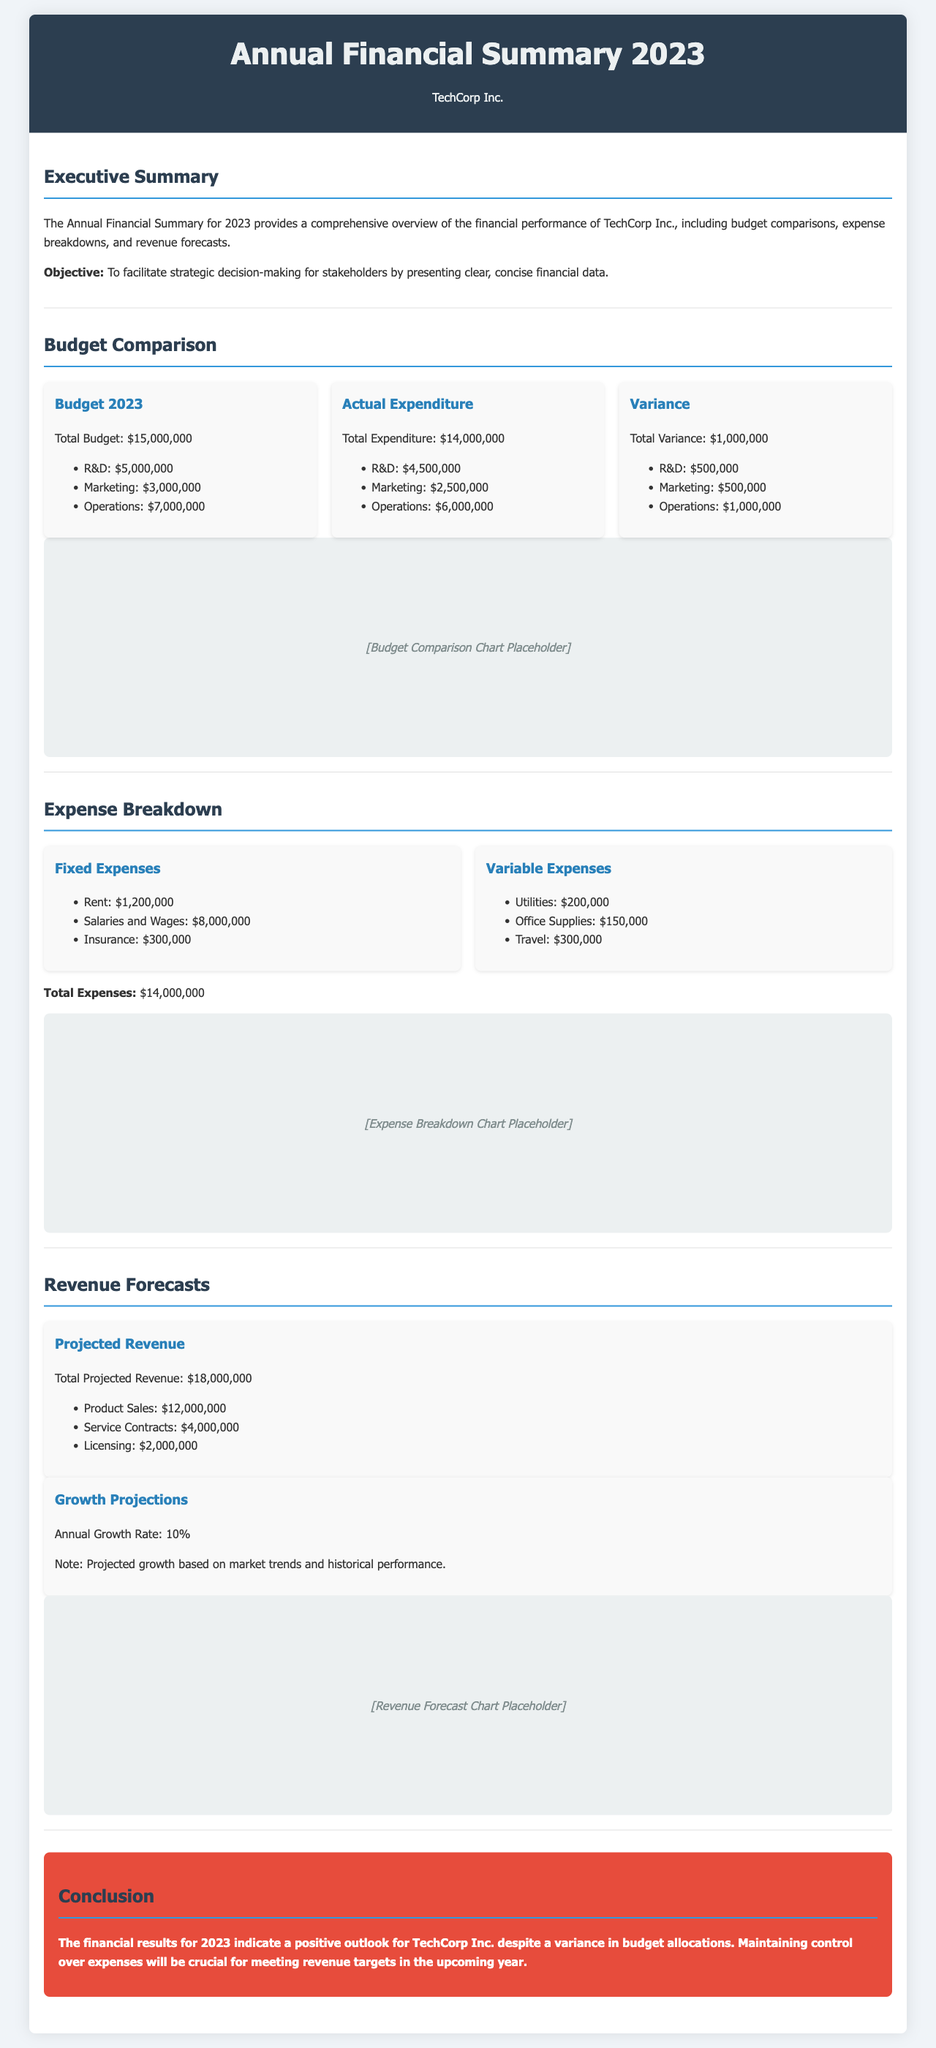What is TechCorp's total budget for 2023? The total budget for 2023 is stated as $15,000,000 in the document.
Answer: $15,000,000 What was the total expenditure for 2023? The document specifies that the total expenditure for 2023 is $14,000,000.
Answer: $14,000,000 What is the total revenue projected for 2023? The projected total revenue for 2023 is mentioned as $18,000,000 in the summary.
Answer: $18,000,000 What is the annual growth rate indicated in the revenue forecasts? The document states that the annual growth rate is 10%.
Answer: 10% How much was spent on Marketing according to the actual expenditure? The actual expenditure on Marketing is listed as $2,500,000 in the budget comparison section.
Answer: $2,500,000 What is the variance in the budget for Operations? The document notes that the variance for Operations is $1,000,000.
Answer: $1,000,000 What category had the highest fixed expense? The highest fixed expense is Salaries and Wages, amounting to $8,000,000.
Answer: Salaries and Wages Which section discusses the financial outlook for the upcoming year? The conclusion section summarizes the financial outlook for TechCorp Inc. in the upcoming year.
Answer: Conclusion What style is used for the document's text? The document uses the 'Segoe UI' font family for its text style.
Answer: 'Segoe UI' 